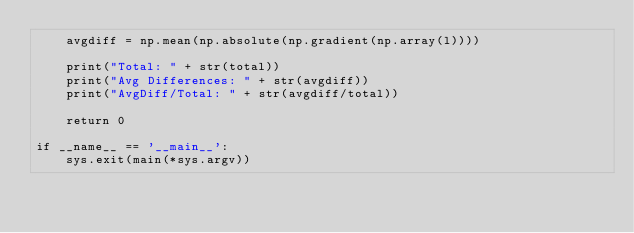Convert code to text. <code><loc_0><loc_0><loc_500><loc_500><_Python_>    avgdiff = np.mean(np.absolute(np.gradient(np.array(l))))

    print("Total: " + str(total))
    print("Avg Differences: " + str(avgdiff))
    print("AvgDiff/Total: " + str(avgdiff/total))

    return 0

if __name__ == '__main__':
    sys.exit(main(*sys.argv))
</code> 